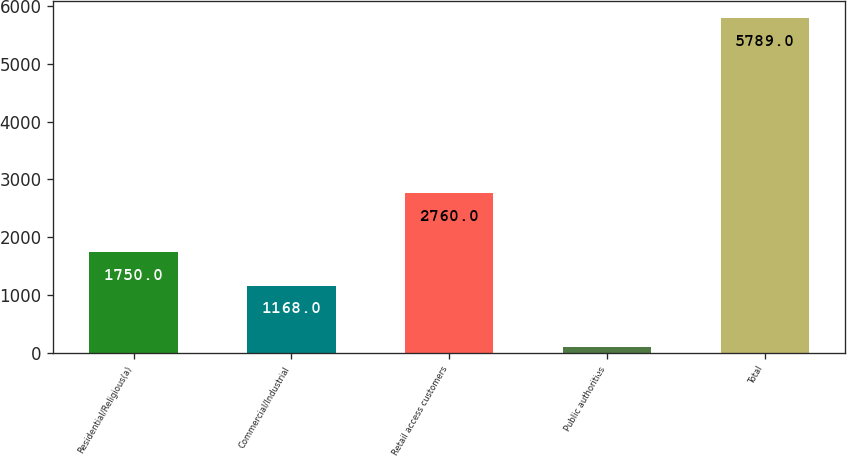Convert chart. <chart><loc_0><loc_0><loc_500><loc_500><bar_chart><fcel>Residential/Religious(a)<fcel>Commercial/Industrial<fcel>Retail access customers<fcel>Public authorities<fcel>Total<nl><fcel>1750<fcel>1168<fcel>2760<fcel>111<fcel>5789<nl></chart> 